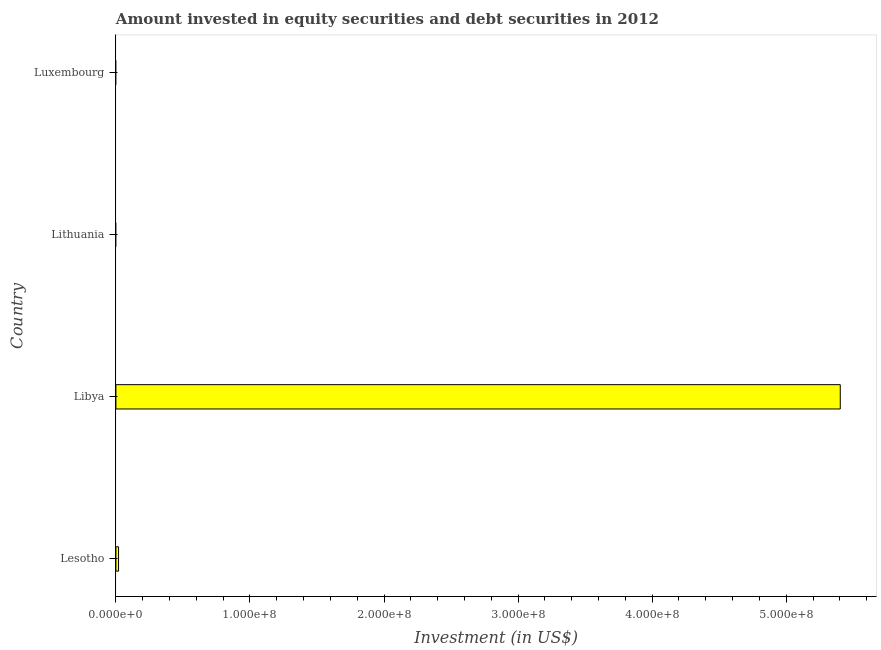Does the graph contain grids?
Make the answer very short. No. What is the title of the graph?
Ensure brevity in your answer.  Amount invested in equity securities and debt securities in 2012. What is the label or title of the X-axis?
Your answer should be very brief. Investment (in US$). What is the portfolio investment in Libya?
Ensure brevity in your answer.  5.40e+08. Across all countries, what is the maximum portfolio investment?
Your response must be concise. 5.40e+08. Across all countries, what is the minimum portfolio investment?
Your answer should be compact. 0. In which country was the portfolio investment maximum?
Your answer should be very brief. Libya. What is the sum of the portfolio investment?
Give a very brief answer. 5.42e+08. What is the difference between the portfolio investment in Lesotho and Libya?
Give a very brief answer. -5.38e+08. What is the average portfolio investment per country?
Make the answer very short. 1.36e+08. What is the median portfolio investment?
Give a very brief answer. 9.93e+05. In how many countries, is the portfolio investment greater than 100000000 US$?
Your answer should be compact. 1. Is the sum of the portfolio investment in Lesotho and Libya greater than the maximum portfolio investment across all countries?
Give a very brief answer. Yes. What is the difference between the highest and the lowest portfolio investment?
Ensure brevity in your answer.  5.40e+08. What is the difference between two consecutive major ticks on the X-axis?
Provide a short and direct response. 1.00e+08. Are the values on the major ticks of X-axis written in scientific E-notation?
Your response must be concise. Yes. What is the Investment (in US$) of Lesotho?
Provide a short and direct response. 1.99e+06. What is the Investment (in US$) of Libya?
Your response must be concise. 5.40e+08. What is the Investment (in US$) of Lithuania?
Provide a short and direct response. 0. What is the Investment (in US$) of Luxembourg?
Give a very brief answer. 0. What is the difference between the Investment (in US$) in Lesotho and Libya?
Ensure brevity in your answer.  -5.38e+08. What is the ratio of the Investment (in US$) in Lesotho to that in Libya?
Provide a succinct answer. 0. 